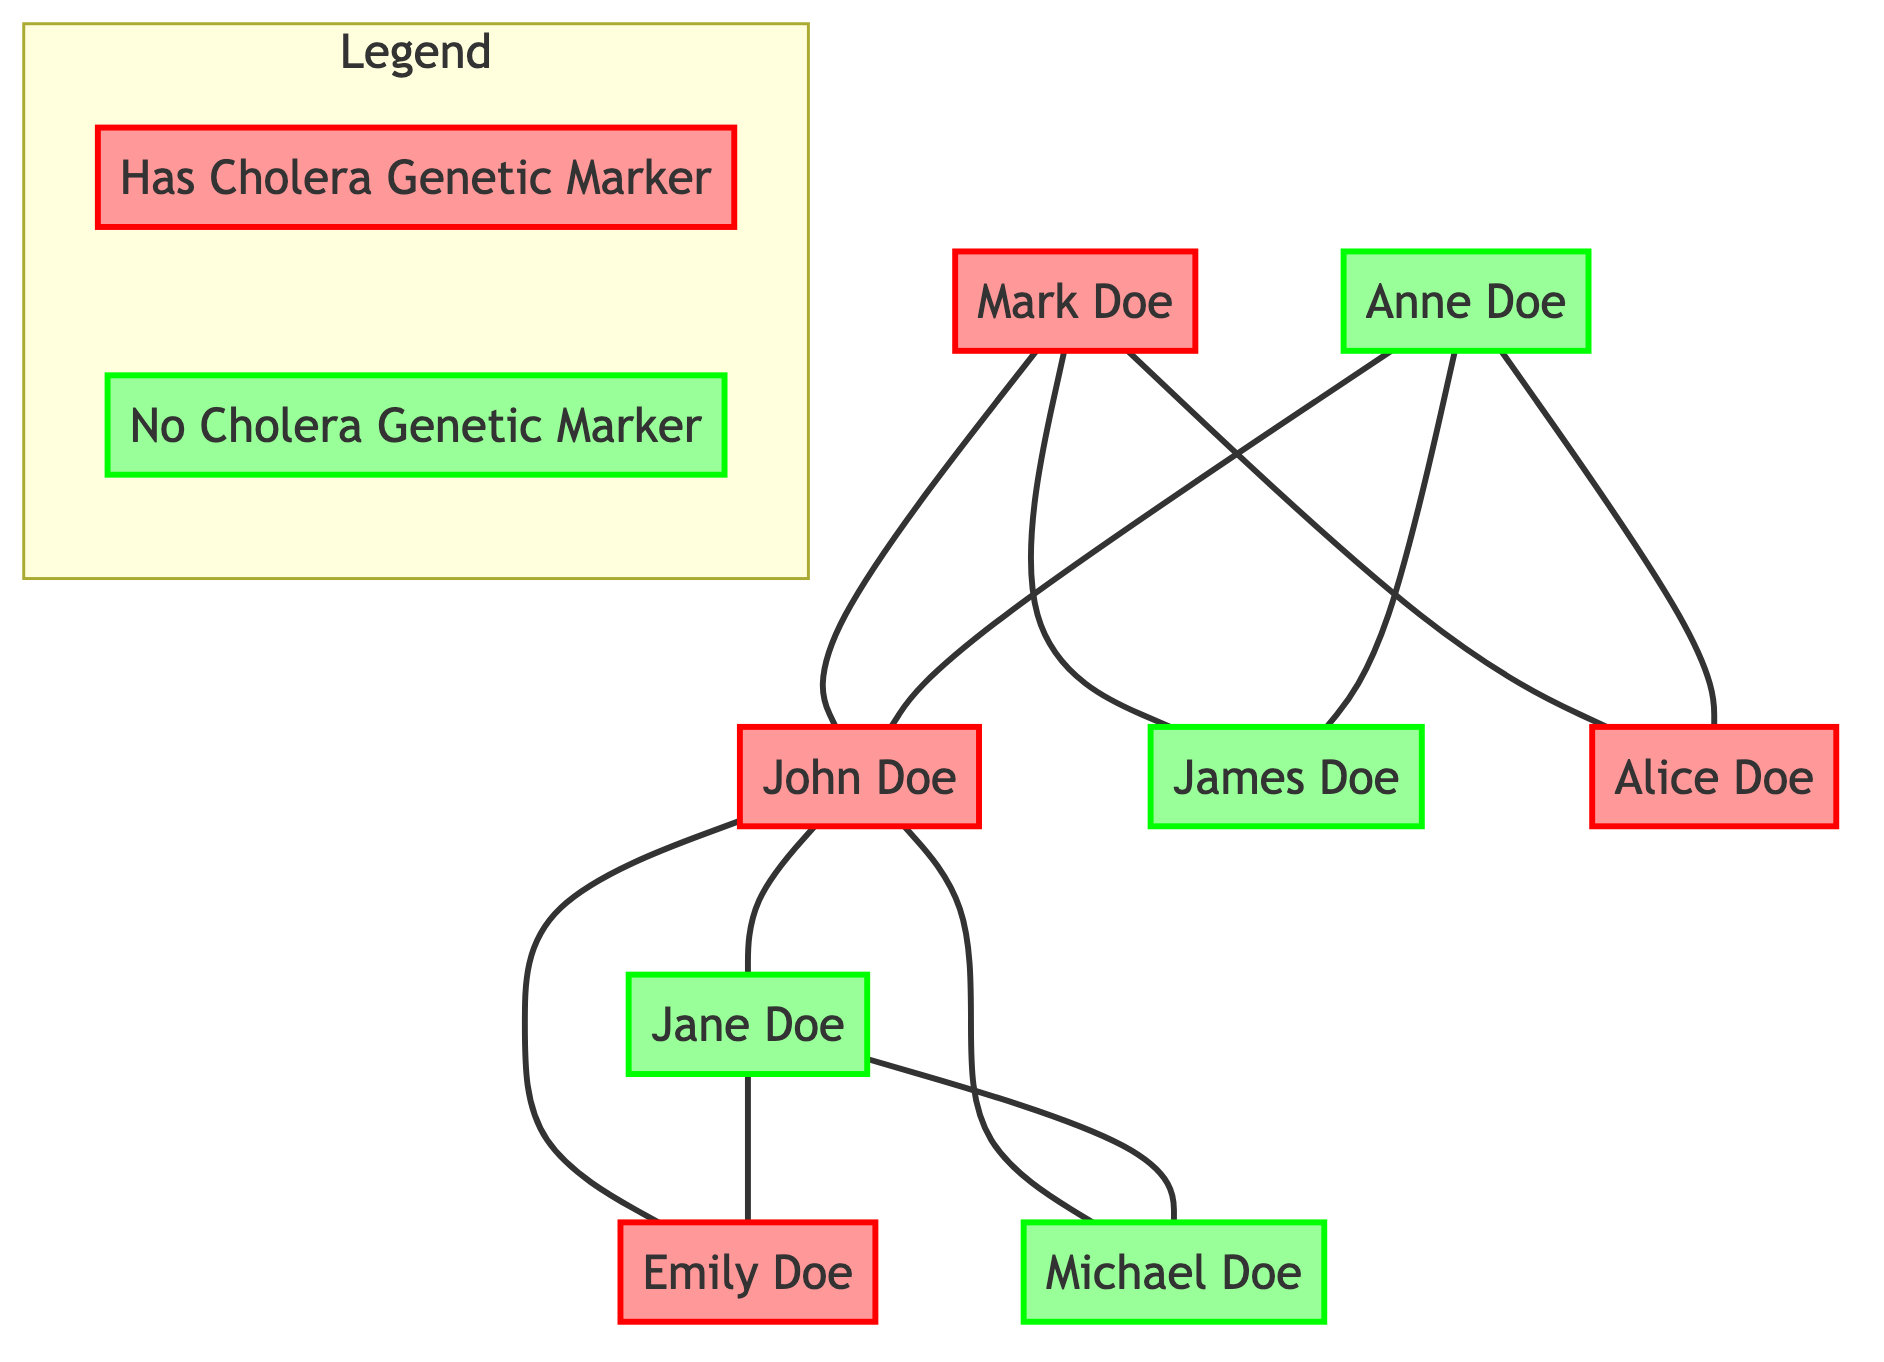What is the relation of Emily Doe to John Doe? Emily Doe is listed as John Doe's daughter in the family tree.
Answer: Daughter How many children does John Doe have? The family tree indicates that John Doe has two children: Emily Doe and Michael Doe.
Answer: 2 Who has the cholera genetic marker in the immediate family? In John Doe's immediate family, both John Doe and Emily Doe have the cholera genetic marker, while Jane Doe and Michael Doe do not.
Answer: John Doe, Emily Doe What is the cholera genetic marker status of Mark Doe? According to the family tree, Mark Doe is indicated to have the cholera genetic marker.
Answer: Has cholera genetic marker Who are the parents of Alice Doe? The family tree indicates that Mark Doe and Anne Doe are the parents of Alice Doe.
Answer: Mark Doe, Anne Doe How many members of John Doe's extended family have the cholera genetic marker? The extended family includes both Mark Doe and Alice Doe, both of whom have the cholera genetic marker, totaling two members.
Answer: 2 What is the relation of James Doe to John Doe? James Doe is identified as John Doe's brother within the family tree.
Answer: Brother How many individuals in the family tree do not have the cholera genetic marker? The individuals without the cholera genetic marker include Jane Doe, Michael Doe, Anne Doe, and James Doe, totaling four individuals.
Answer: 4 Which family member is the spouse of John Doe? The diagram indicates that Jane Doe is the spouse of John Doe.
Answer: Jane Doe 